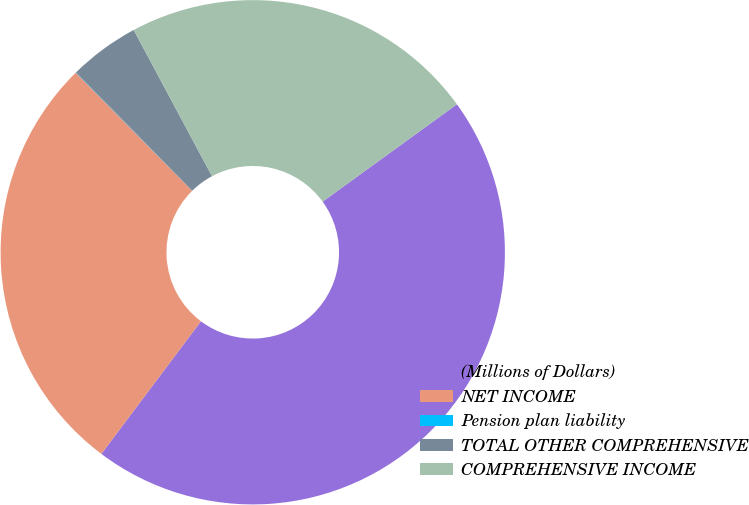Convert chart. <chart><loc_0><loc_0><loc_500><loc_500><pie_chart><fcel>(Millions of Dollars)<fcel>NET INCOME<fcel>Pension plan liability<fcel>TOTAL OTHER COMPREHENSIVE<fcel>COMPREHENSIVE INCOME<nl><fcel>45.23%<fcel>27.36%<fcel>0.02%<fcel>4.54%<fcel>22.84%<nl></chart> 